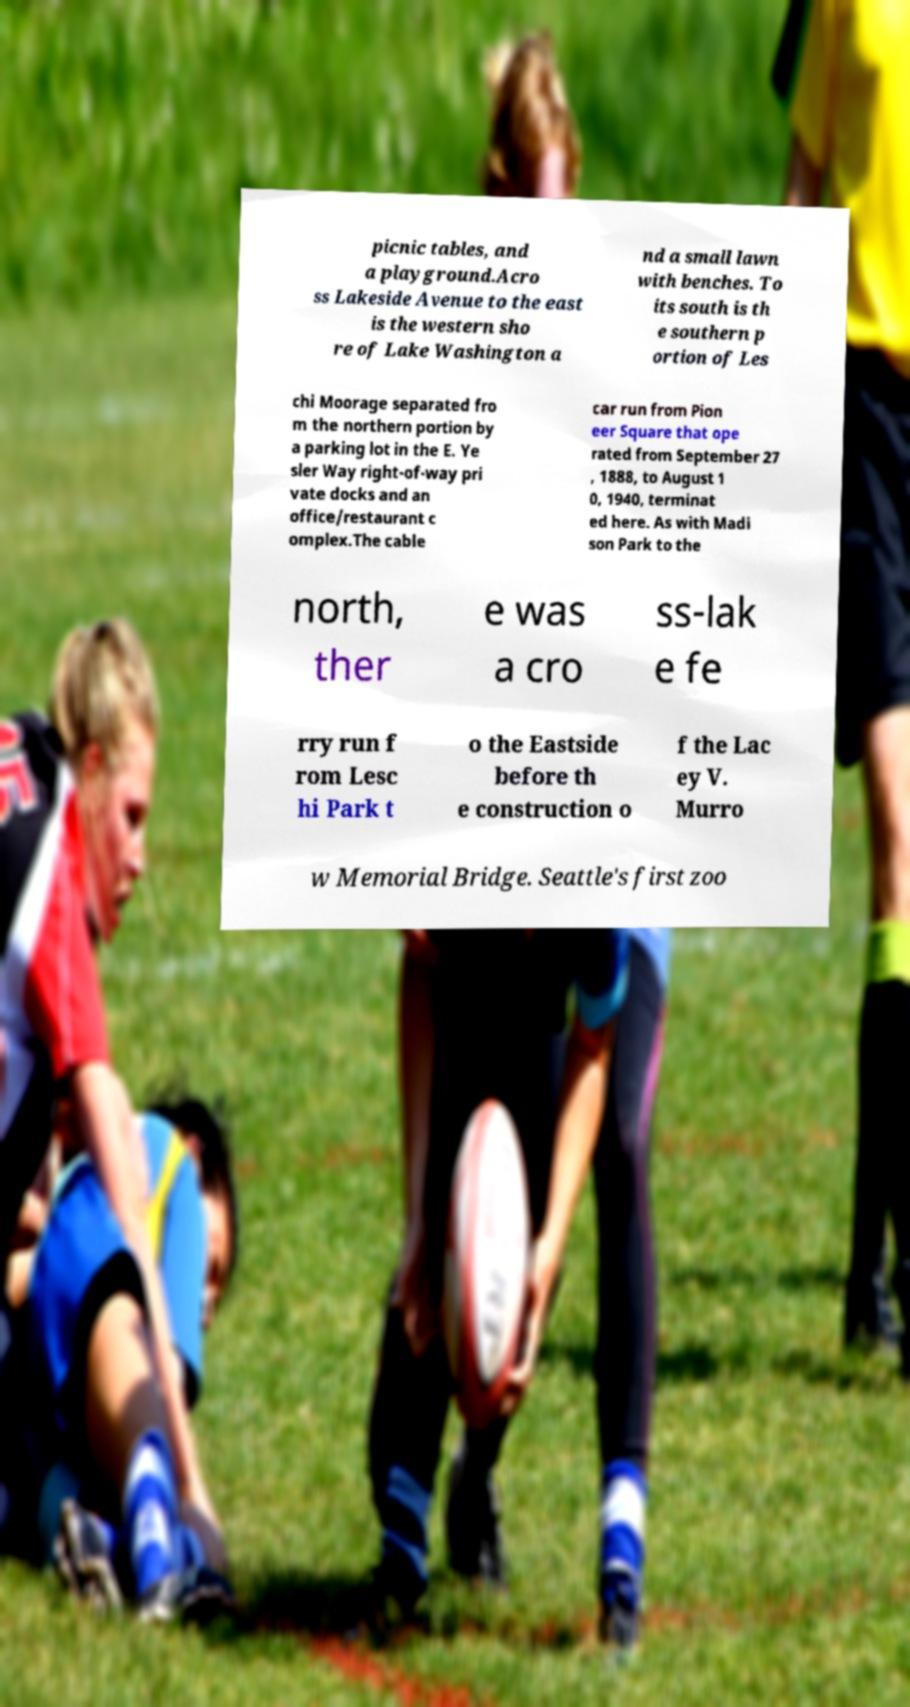Could you extract and type out the text from this image? picnic tables, and a playground.Acro ss Lakeside Avenue to the east is the western sho re of Lake Washington a nd a small lawn with benches. To its south is th e southern p ortion of Les chi Moorage separated fro m the northern portion by a parking lot in the E. Ye sler Way right-of-way pri vate docks and an office/restaurant c omplex.The cable car run from Pion eer Square that ope rated from September 27 , 1888, to August 1 0, 1940, terminat ed here. As with Madi son Park to the north, ther e was a cro ss-lak e fe rry run f rom Lesc hi Park t o the Eastside before th e construction o f the Lac ey V. Murro w Memorial Bridge. Seattle's first zoo 